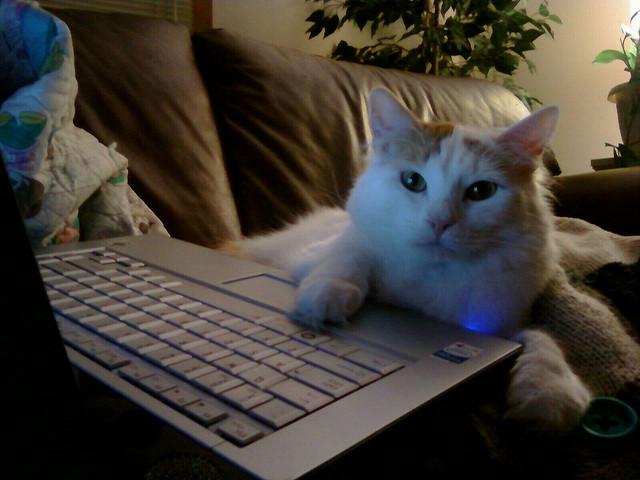What is the cat typing?
Give a very brief answer. Nothing. What color is the cat?
Write a very short answer. White and orange. Is the cat learning how to type?
Short answer required. No. How many cats are shown?
Quick response, please. 1. What is the cat sitting next to?
Be succinct. Laptop. Does the cat have red eyes?
Write a very short answer. No. How many lights are on the side of the laptop?
Write a very short answer. 1. Is the kitty cat going to put his paw on the keyboard?
Concise answer only. Yes. Is the computer on or off?
Give a very brief answer. On. What is the cat looking at?
Be succinct. Camera. Was the photographer far from the cat when taking this photo?
Short answer required. No. Is the cat sleeping?
Write a very short answer. No. What color are the eyes?
Quick response, please. Green. Is the cat awake?
Answer briefly. Yes. Is the cat laying near a laptop and other electronics?
Concise answer only. Yes. 